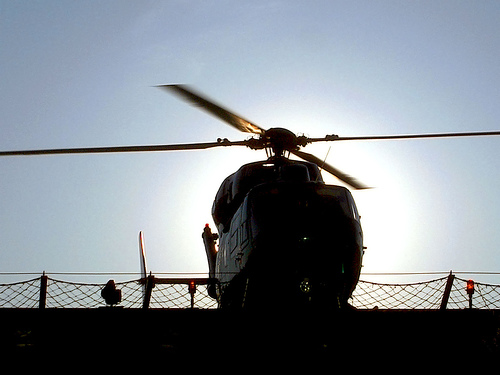<image>
Is there a helicopter in front of the helipad? No. The helicopter is not in front of the helipad. The spatial positioning shows a different relationship between these objects. 